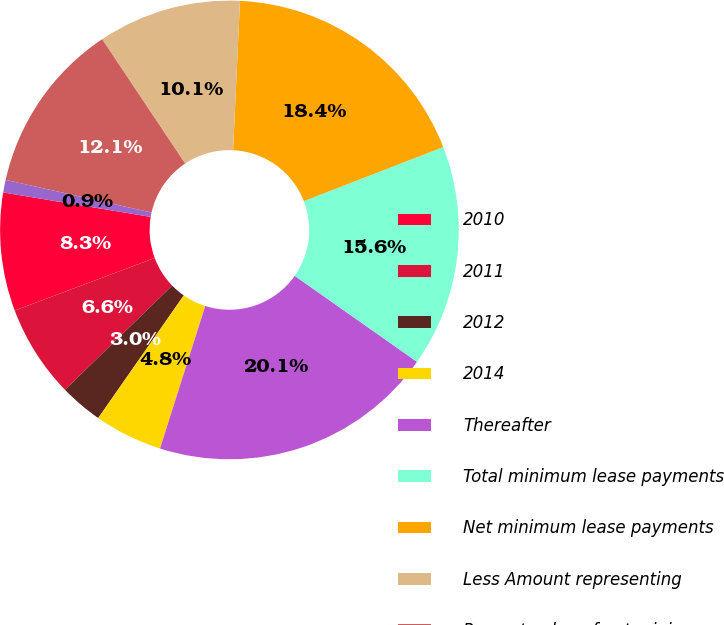Convert chart to OTSL. <chart><loc_0><loc_0><loc_500><loc_500><pie_chart><fcel>2010<fcel>2011<fcel>2012<fcel>2014<fcel>Thereafter<fcel>Total minimum lease payments<fcel>Net minimum lease payments<fcel>Less Amount representing<fcel>Present value of net minimum<fcel>Less Current portion<nl><fcel>8.33%<fcel>6.56%<fcel>3.03%<fcel>4.8%<fcel>20.14%<fcel>15.64%<fcel>18.38%<fcel>10.1%<fcel>12.13%<fcel>0.89%<nl></chart> 